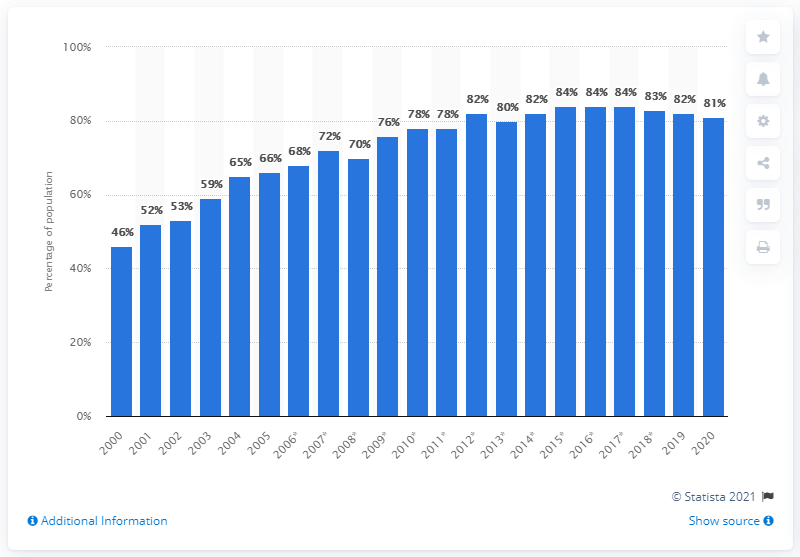Outline some significant characteristics in this image. In 2020, there was a slight decrease in the penetration of devices, such as PCs, laptops, and tablet computers, that were able to connect to the internet. 